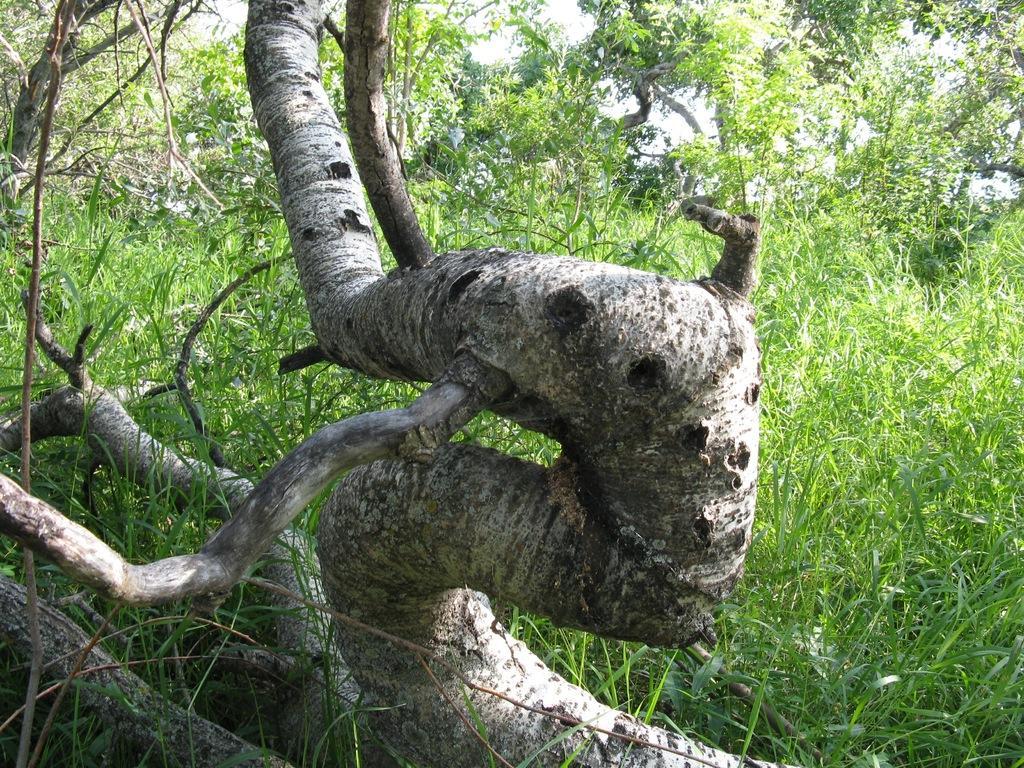Could you give a brief overview of what you see in this image? The picture consists of trees. In the foreground of the picture there is a trunk of a tree. 